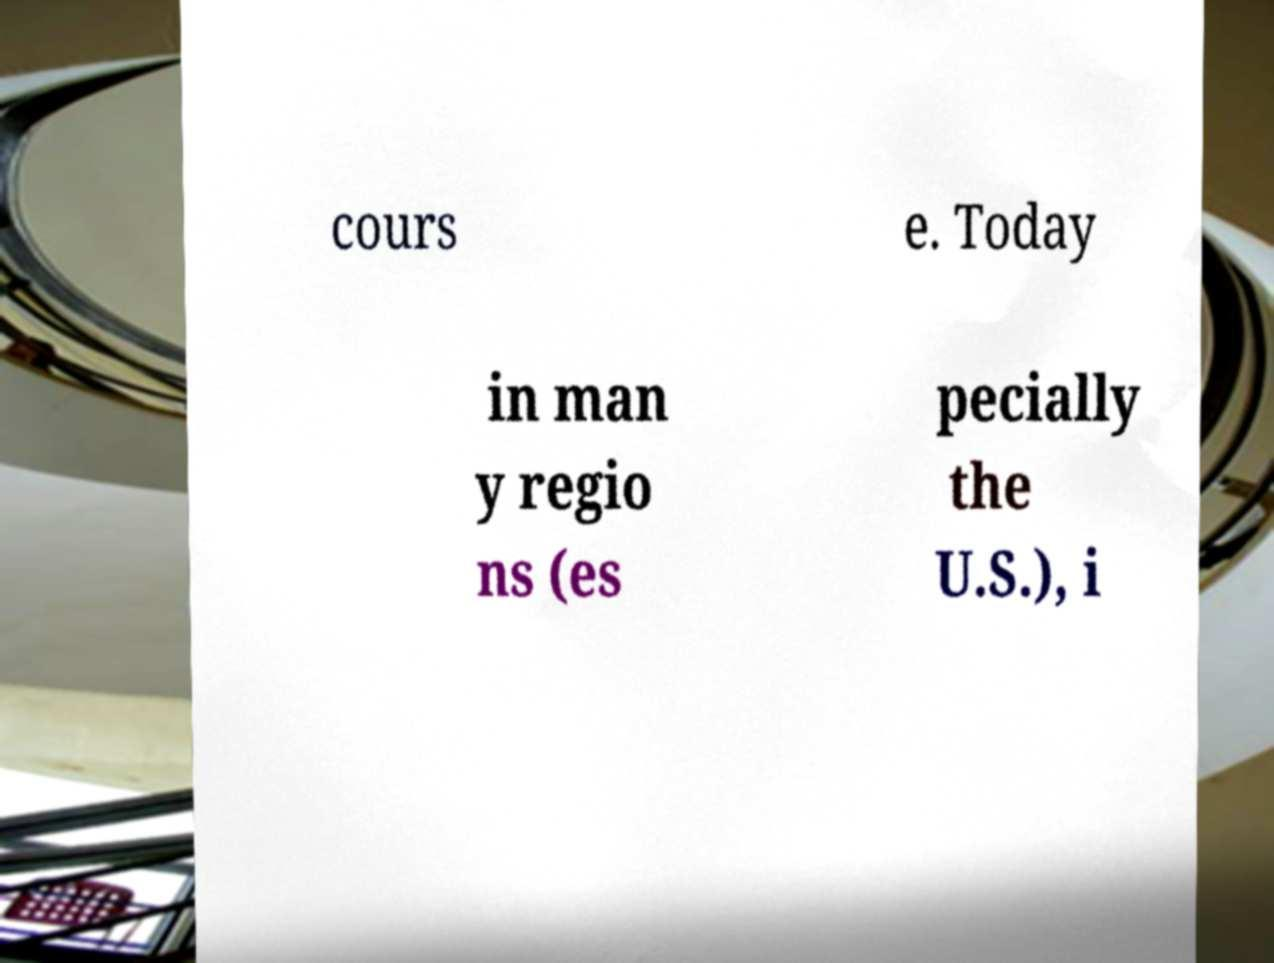Could you assist in decoding the text presented in this image and type it out clearly? cours e. Today in man y regio ns (es pecially the U.S.), i 